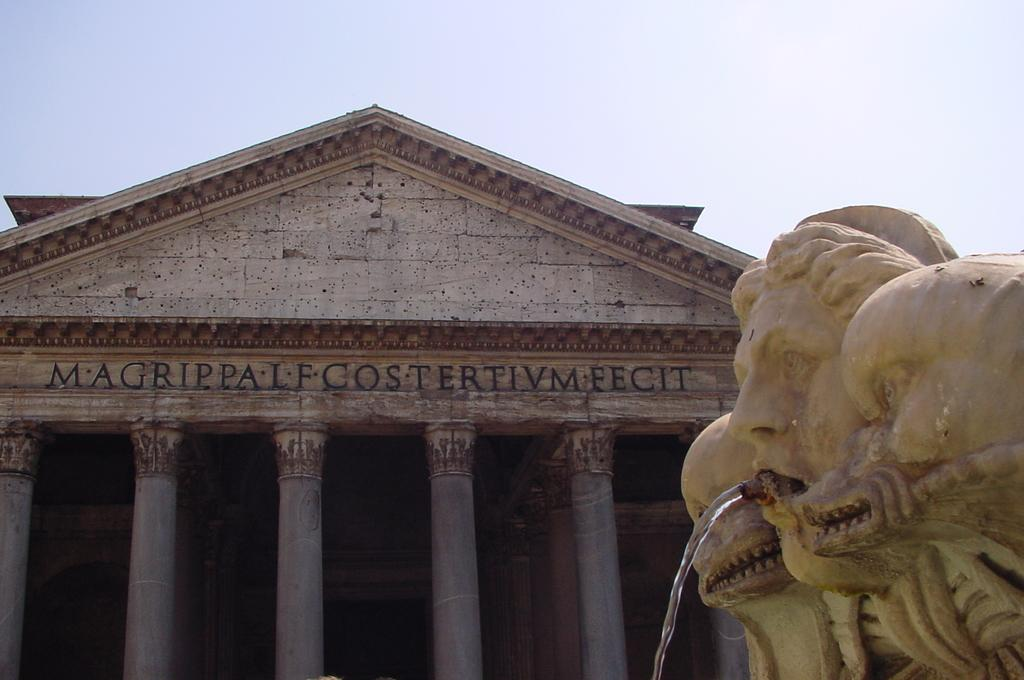What is the main subject in the image? There is a statue in the image. What is the statue doing in the image? Water is flowing from the mouth of the statue. What can be seen behind the statue? There is a building behind the statue. What is the name of the building? The building has a name. What architectural feature can be seen on the building? The building has pillars. What decision does the statue make in the image? The statue does not make any decisions in the image; it is a stationary object with water flowing from its mouth. 